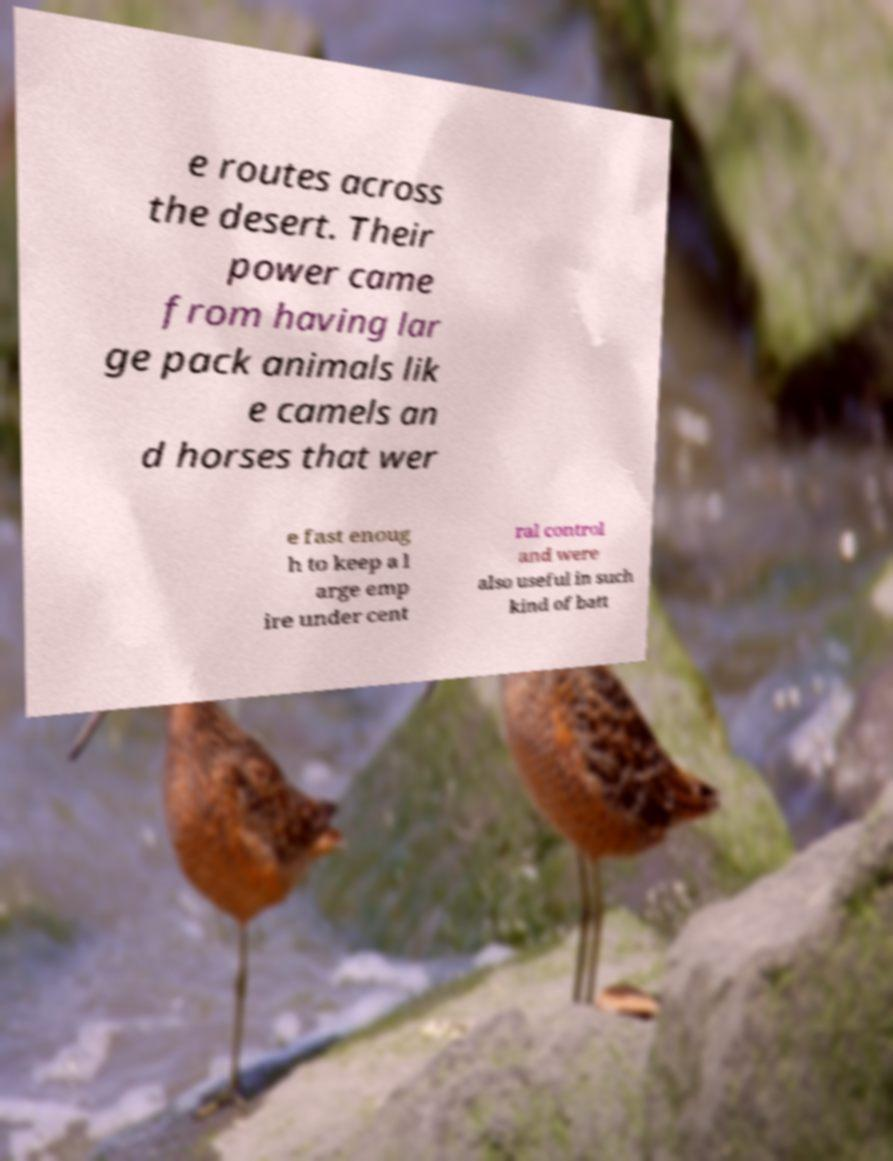Could you extract and type out the text from this image? e routes across the desert. Their power came from having lar ge pack animals lik e camels an d horses that wer e fast enoug h to keep a l arge emp ire under cent ral control and were also useful in such kind of batt 